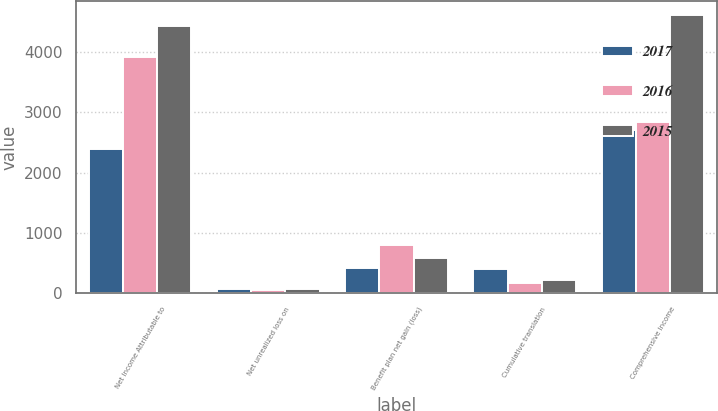Convert chart to OTSL. <chart><loc_0><loc_0><loc_500><loc_500><stacked_bar_chart><ecel><fcel>Net Income Attributable to<fcel>Net unrealized loss on<fcel>Benefit plan net gain (loss)<fcel>Cumulative translation<fcel>Comprehensive Income<nl><fcel>2017<fcel>2394<fcel>58<fcel>419<fcel>401<fcel>2710<nl><fcel>2016<fcel>3920<fcel>44<fcel>799<fcel>169<fcel>2842<nl><fcel>2015<fcel>4442<fcel>70<fcel>579<fcel>208<fcel>4617<nl></chart> 